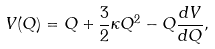<formula> <loc_0><loc_0><loc_500><loc_500>V ( Q ) = Q + \frac { 3 } { 2 } \kappa Q ^ { 2 } - Q \frac { d V } { d Q } ,</formula> 